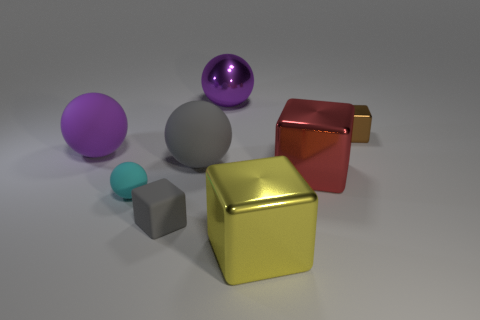Could you describe the lighting in this image? Where is the light source? The lighting in the image is subtle and appears to be coming from the upper left as evidenced by the soft shadows cast to the lower right of the objects. The light source itself isn't visible in the image, but its effects suggest a single, diffused light source, giving the objects a gentle illumination and a slight gradient in the backdrop. 